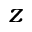Convert formula to latex. <formula><loc_0><loc_0><loc_500><loc_500>z</formula> 